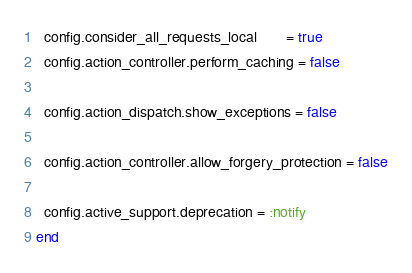Convert code to text. <code><loc_0><loc_0><loc_500><loc_500><_Ruby_>  config.consider_all_requests_local       = true
  config.action_controller.perform_caching = false

  config.action_dispatch.show_exceptions = false

  config.action_controller.allow_forgery_protection = false

  config.active_support.deprecation = :notify
end
</code> 